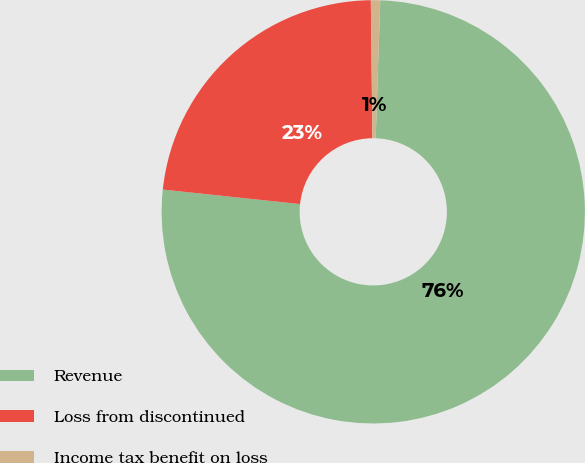Convert chart. <chart><loc_0><loc_0><loc_500><loc_500><pie_chart><fcel>Revenue<fcel>Loss from discontinued<fcel>Income tax benefit on loss<nl><fcel>76.15%<fcel>23.14%<fcel>0.71%<nl></chart> 